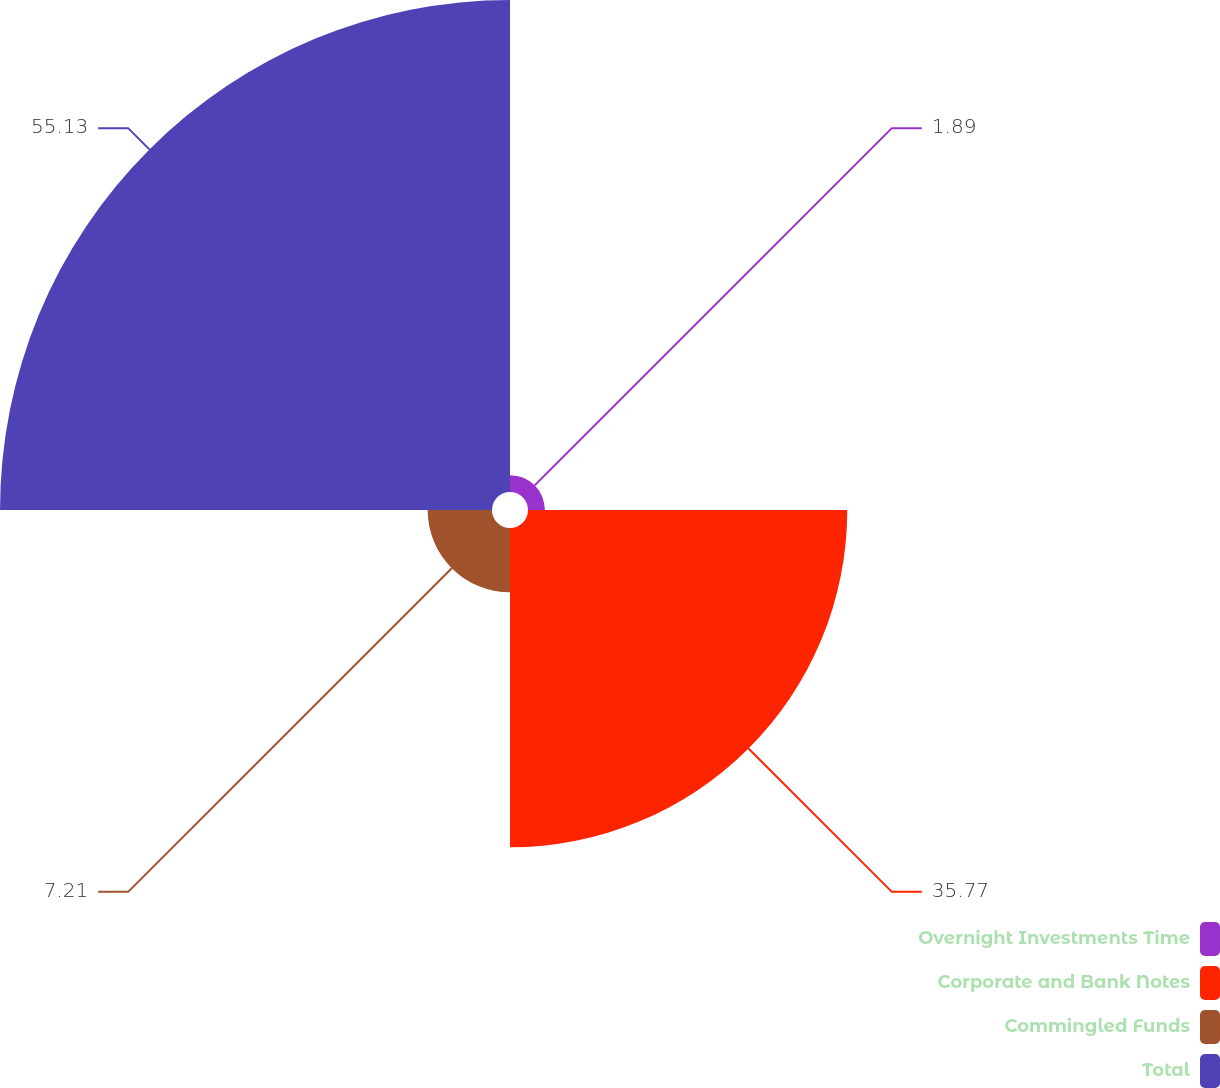Convert chart to OTSL. <chart><loc_0><loc_0><loc_500><loc_500><pie_chart><fcel>Overnight Investments Time<fcel>Corporate and Bank Notes<fcel>Commingled Funds<fcel>Total<nl><fcel>1.89%<fcel>35.77%<fcel>7.21%<fcel>55.12%<nl></chart> 